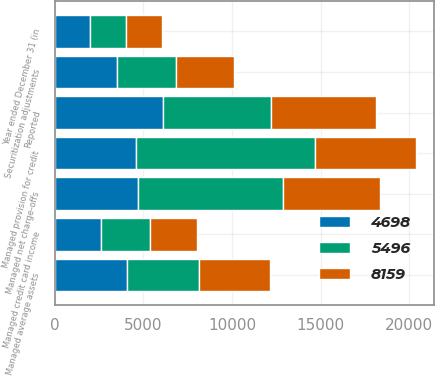Convert chart. <chart><loc_0><loc_0><loc_500><loc_500><stacked_bar_chart><ecel><fcel>Year ended December 31 (in<fcel>Reported<fcel>Securitization adjustments<fcel>Managed credit card income<fcel>Managed provision for credit<fcel>Managed average assets<fcel>Managed net charge-offs<nl><fcel>5496<fcel>2008<fcel>6082<fcel>3314<fcel>2768<fcel>10059<fcel>4053.5<fcel>8159<nl><fcel>8159<fcel>2007<fcel>5940<fcel>3255<fcel>2685<fcel>5711<fcel>4053.5<fcel>5496<nl><fcel>4698<fcel>2006<fcel>6096<fcel>3509<fcel>2587<fcel>4598<fcel>4053.5<fcel>4698<nl></chart> 